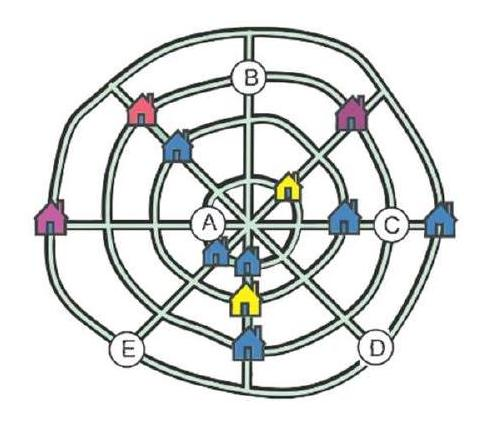A village of 12 houses has four straight streets and four circular streets. The map shows 11 houses. In each straight street there are three houses and in each circular street there are also three houses. Where should the 12th house be placed on this map? Choices: ['On A', 'On B', 'On C', 'On D', 'On E'] After careful inspection of the map, it is evident that option D is the correct placement for the 12th house. This is because if we follow the pattern of the existing houses, each straight and circular street contains three houses. By placing the 12th house on D, we maintain this consistent pattern, ensuring that all streets have an equal number of houses, adhering to the unique urban design presented on this map. 